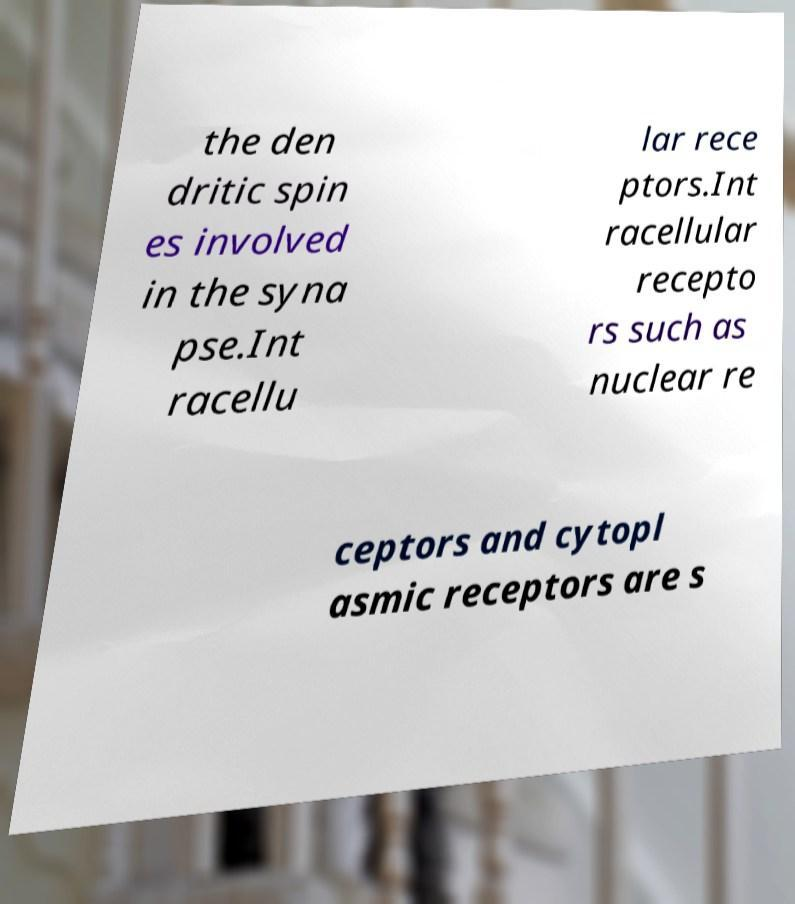Could you assist in decoding the text presented in this image and type it out clearly? the den dritic spin es involved in the syna pse.Int racellu lar rece ptors.Int racellular recepto rs such as nuclear re ceptors and cytopl asmic receptors are s 